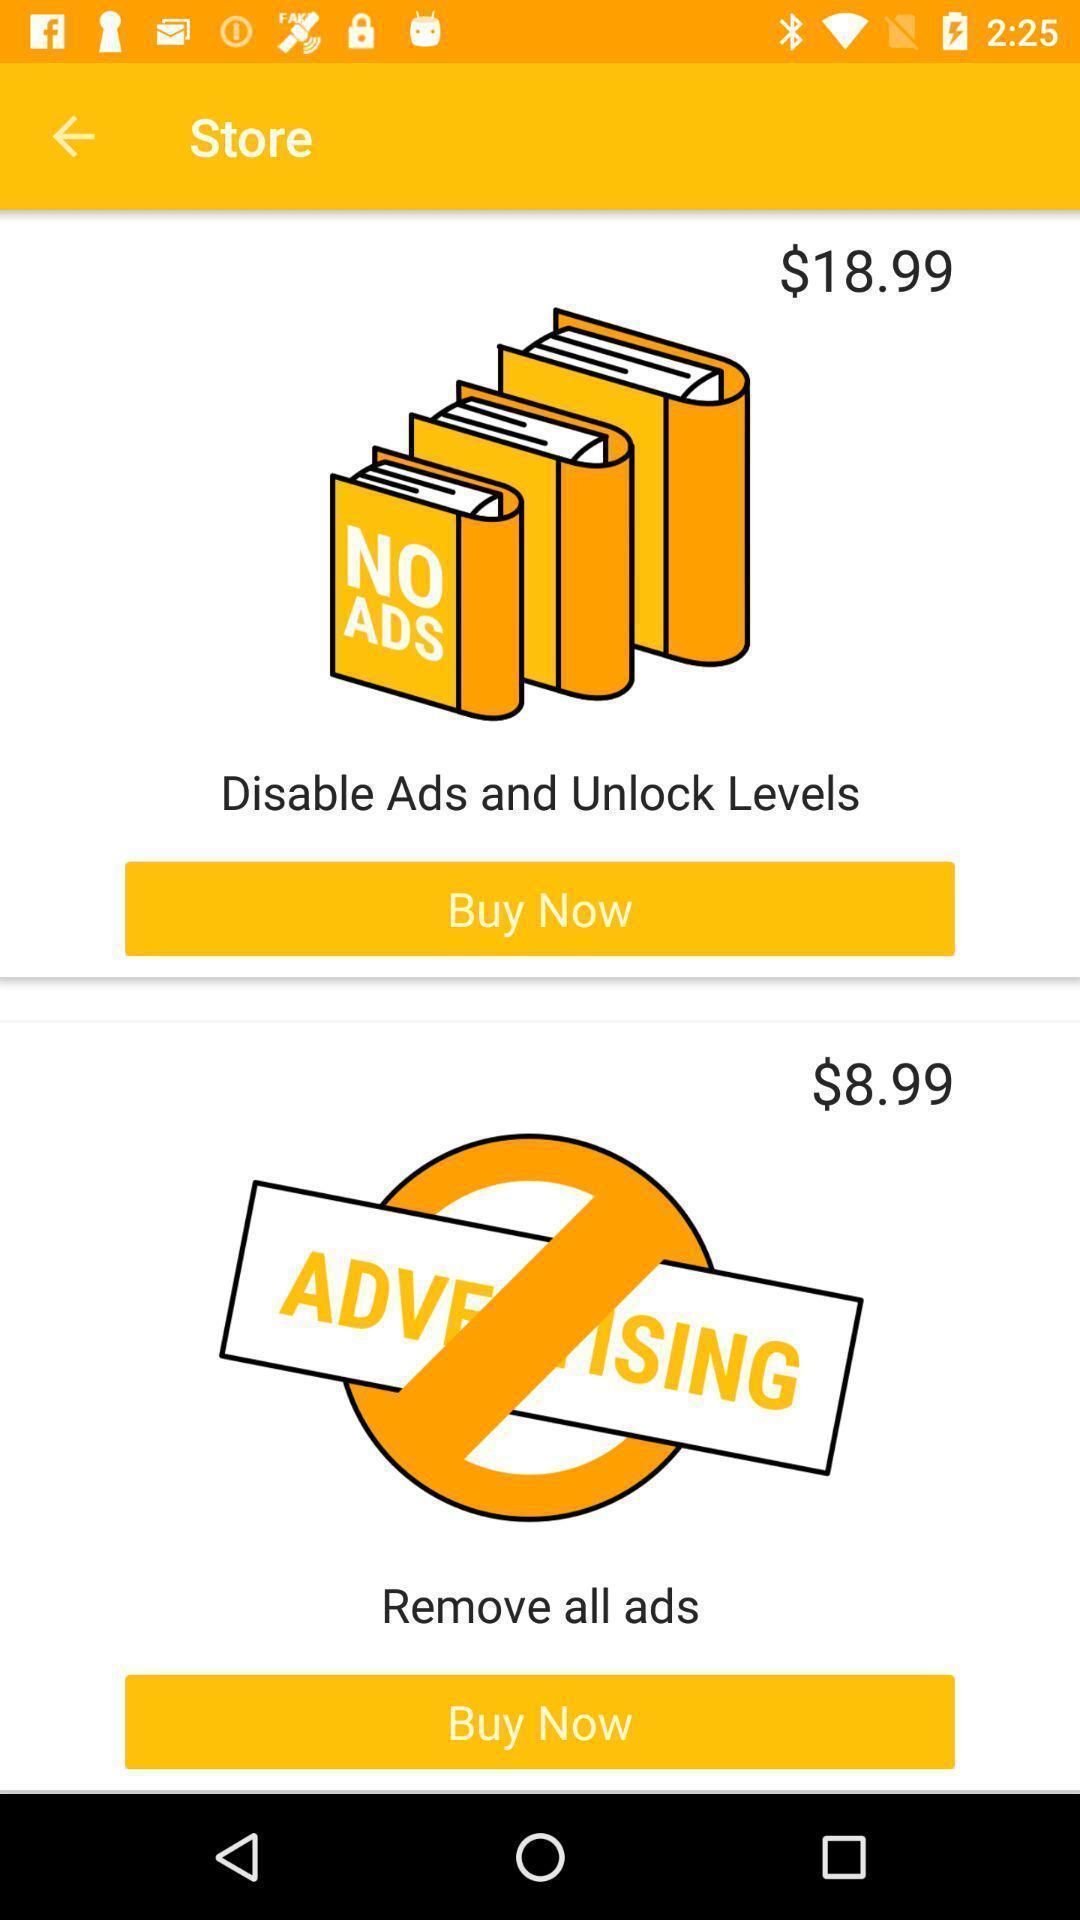Provide a textual representation of this image. Page displaying the ads of an advertisements. 